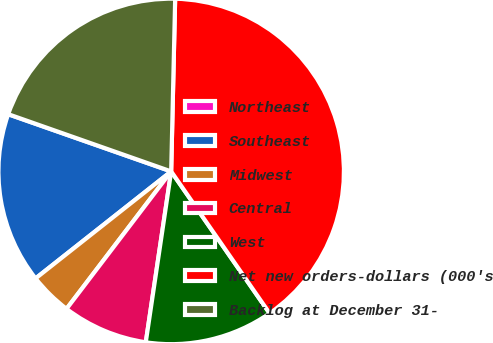Convert chart. <chart><loc_0><loc_0><loc_500><loc_500><pie_chart><fcel>Northeast<fcel>Southeast<fcel>Midwest<fcel>Central<fcel>West<fcel>Net new orders-dollars (000's<fcel>Backlog at December 31-<nl><fcel>0.01%<fcel>16.0%<fcel>4.01%<fcel>8.01%<fcel>12.0%<fcel>39.98%<fcel>19.99%<nl></chart> 